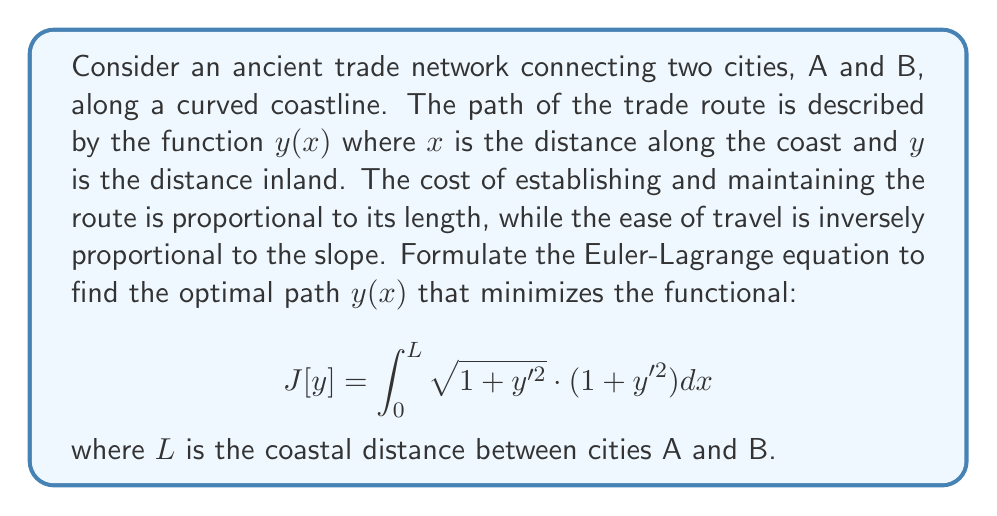Can you solve this math problem? To solve this problem using calculus of variations, we need to follow these steps:

1) The Euler-Lagrange equation is given by:

   $$ \frac{\partial F}{\partial y} - \frac{d}{dx}\left(\frac{\partial F}{\partial y'}\right) = 0 $$

   where $F(x,y,y') = \sqrt{1 + y'^2} \cdot (1 + y'^2)$

2) Calculate $\frac{\partial F}{\partial y}$:
   
   $\frac{\partial F}{\partial y} = 0$ (as $F$ doesn't explicitly depend on $y$)

3) Calculate $\frac{\partial F}{\partial y'}$:
   
   $$ \frac{\partial F}{\partial y'} = \frac{2y'}{\sqrt{1+y'^2}} \cdot (1+y'^2) + \sqrt{1+y'^2} \cdot 2y' $$
   $$ = 2y'\sqrt{1+y'^2} + 2y'\sqrt{1+y'^2} = 4y'\sqrt{1+y'^2} $$

4) Calculate $\frac{d}{dx}\left(\frac{\partial F}{\partial y'}\right)$:
   
   $$ \frac{d}{dx}\left(4y'\sqrt{1+y'^2}\right) = 4\frac{d}{dx}(y'\sqrt{1+y'^2}) $$
   $$ = 4\left(\frac{d}{dx}(y')\sqrt{1+y'^2} + y'\frac{d}{dx}(\sqrt{1+y'^2})\right) $$
   $$ = 4\left(y''\sqrt{1+y'^2} + y'\frac{y'y'')}{\sqrt{1+y'^2}}\right) $$
   $$ = 4y''\sqrt{1+y'^2} + \frac{4y'^2y''}{\sqrt{1+y'^2}} $$

5) Substitute into the Euler-Lagrange equation:

   $$ 0 - \left(4y''\sqrt{1+y'^2} + \frac{4y'^2y''}{\sqrt{1+y'^2}}\right) = 0 $$

6) Simplify:
   
   $$ 4y''\sqrt{1+y'^2} + \frac{4y'^2y''}{\sqrt{1+y'^2}} = 0 $$
   $$ 4y''(1+y'^2) = 0 $$
   $$ y''(1+y'^2) = 0 $$

7) Solve the differential equation:
   
   Either $y'' = 0$ or $1+y'^2 = 0$
   
   $1+y'^2 = 0$ has no real solutions, so $y'' = 0$

   This implies that $y' = C$ (constant), and $y = Cx + D$

Therefore, the optimal path is a straight line between the two cities.
Answer: $y = Cx + D$ (straight line) 